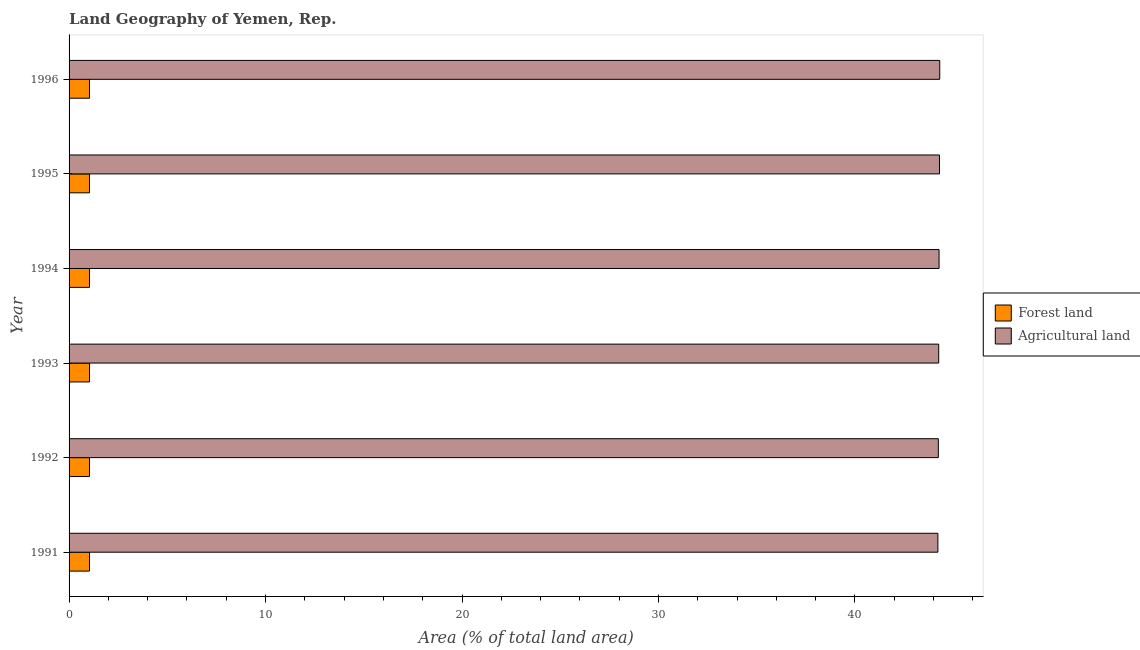How many different coloured bars are there?
Offer a very short reply. 2. How many groups of bars are there?
Ensure brevity in your answer.  6. Are the number of bars per tick equal to the number of legend labels?
Keep it short and to the point. Yes. How many bars are there on the 5th tick from the bottom?
Give a very brief answer. 2. What is the label of the 5th group of bars from the top?
Make the answer very short. 1992. In how many cases, is the number of bars for a given year not equal to the number of legend labels?
Give a very brief answer. 0. What is the percentage of land area under agriculture in 1994?
Your answer should be compact. 44.28. Across all years, what is the maximum percentage of land area under forests?
Provide a short and direct response. 1.04. Across all years, what is the minimum percentage of land area under agriculture?
Give a very brief answer. 44.22. What is the total percentage of land area under forests in the graph?
Provide a succinct answer. 6.24. What is the difference between the percentage of land area under forests in 1994 and the percentage of land area under agriculture in 1996?
Give a very brief answer. -43.28. What is the average percentage of land area under forests per year?
Provide a short and direct response. 1.04. In the year 1993, what is the difference between the percentage of land area under forests and percentage of land area under agriculture?
Make the answer very short. -43.22. In how many years, is the percentage of land area under agriculture greater than 36 %?
Your answer should be compact. 6. Is the percentage of land area under agriculture in 1994 less than that in 1996?
Your answer should be compact. Yes. Is the difference between the percentage of land area under agriculture in 1994 and 1995 greater than the difference between the percentage of land area under forests in 1994 and 1995?
Offer a very short reply. No. What is the difference between the highest and the second highest percentage of land area under forests?
Provide a succinct answer. 0. What is the difference between the highest and the lowest percentage of land area under agriculture?
Provide a short and direct response. 0.09. In how many years, is the percentage of land area under forests greater than the average percentage of land area under forests taken over all years?
Your answer should be very brief. 6. Is the sum of the percentage of land area under forests in 1993 and 1996 greater than the maximum percentage of land area under agriculture across all years?
Ensure brevity in your answer.  No. What does the 1st bar from the top in 1992 represents?
Your response must be concise. Agricultural land. What does the 2nd bar from the bottom in 1996 represents?
Your answer should be very brief. Agricultural land. Are the values on the major ticks of X-axis written in scientific E-notation?
Provide a short and direct response. No. Does the graph contain grids?
Ensure brevity in your answer.  No. What is the title of the graph?
Offer a very short reply. Land Geography of Yemen, Rep. Does "Pregnant women" appear as one of the legend labels in the graph?
Provide a short and direct response. No. What is the label or title of the X-axis?
Your answer should be very brief. Area (% of total land area). What is the Area (% of total land area) in Forest land in 1991?
Provide a succinct answer. 1.04. What is the Area (% of total land area) of Agricultural land in 1991?
Keep it short and to the point. 44.22. What is the Area (% of total land area) in Forest land in 1992?
Make the answer very short. 1.04. What is the Area (% of total land area) in Agricultural land in 1992?
Ensure brevity in your answer.  44.24. What is the Area (% of total land area) of Forest land in 1993?
Your answer should be compact. 1.04. What is the Area (% of total land area) of Agricultural land in 1993?
Keep it short and to the point. 44.26. What is the Area (% of total land area) of Forest land in 1994?
Keep it short and to the point. 1.04. What is the Area (% of total land area) in Agricultural land in 1994?
Offer a terse response. 44.28. What is the Area (% of total land area) of Forest land in 1995?
Ensure brevity in your answer.  1.04. What is the Area (% of total land area) in Agricultural land in 1995?
Your answer should be compact. 44.3. What is the Area (% of total land area) in Forest land in 1996?
Keep it short and to the point. 1.04. What is the Area (% of total land area) of Agricultural land in 1996?
Provide a short and direct response. 44.32. Across all years, what is the maximum Area (% of total land area) of Forest land?
Give a very brief answer. 1.04. Across all years, what is the maximum Area (% of total land area) of Agricultural land?
Your response must be concise. 44.32. Across all years, what is the minimum Area (% of total land area) in Forest land?
Offer a very short reply. 1.04. Across all years, what is the minimum Area (% of total land area) in Agricultural land?
Your answer should be very brief. 44.22. What is the total Area (% of total land area) in Forest land in the graph?
Offer a terse response. 6.24. What is the total Area (% of total land area) in Agricultural land in the graph?
Provide a short and direct response. 265.63. What is the difference between the Area (% of total land area) in Agricultural land in 1991 and that in 1992?
Offer a very short reply. -0.02. What is the difference between the Area (% of total land area) in Forest land in 1991 and that in 1993?
Offer a very short reply. 0. What is the difference between the Area (% of total land area) of Agricultural land in 1991 and that in 1993?
Your answer should be compact. -0.04. What is the difference between the Area (% of total land area) of Forest land in 1991 and that in 1994?
Your answer should be compact. 0. What is the difference between the Area (% of total land area) in Agricultural land in 1991 and that in 1994?
Your answer should be very brief. -0.06. What is the difference between the Area (% of total land area) of Agricultural land in 1991 and that in 1995?
Provide a short and direct response. -0.08. What is the difference between the Area (% of total land area) in Forest land in 1991 and that in 1996?
Provide a succinct answer. 0. What is the difference between the Area (% of total land area) in Agricultural land in 1991 and that in 1996?
Provide a succinct answer. -0.09. What is the difference between the Area (% of total land area) in Forest land in 1992 and that in 1993?
Your response must be concise. 0. What is the difference between the Area (% of total land area) of Agricultural land in 1992 and that in 1993?
Offer a terse response. -0.02. What is the difference between the Area (% of total land area) in Forest land in 1992 and that in 1994?
Offer a very short reply. 0. What is the difference between the Area (% of total land area) in Agricultural land in 1992 and that in 1994?
Your response must be concise. -0.04. What is the difference between the Area (% of total land area) in Forest land in 1992 and that in 1995?
Offer a terse response. 0. What is the difference between the Area (% of total land area) in Agricultural land in 1992 and that in 1995?
Keep it short and to the point. -0.06. What is the difference between the Area (% of total land area) of Agricultural land in 1992 and that in 1996?
Provide a succinct answer. -0.07. What is the difference between the Area (% of total land area) of Forest land in 1993 and that in 1994?
Provide a short and direct response. 0. What is the difference between the Area (% of total land area) in Agricultural land in 1993 and that in 1994?
Provide a short and direct response. -0.02. What is the difference between the Area (% of total land area) of Forest land in 1993 and that in 1995?
Your answer should be very brief. 0. What is the difference between the Area (% of total land area) of Agricultural land in 1993 and that in 1995?
Provide a short and direct response. -0.04. What is the difference between the Area (% of total land area) of Forest land in 1993 and that in 1996?
Your answer should be very brief. 0. What is the difference between the Area (% of total land area) of Agricultural land in 1993 and that in 1996?
Offer a terse response. -0.05. What is the difference between the Area (% of total land area) in Agricultural land in 1994 and that in 1995?
Offer a very short reply. -0.02. What is the difference between the Area (% of total land area) in Forest land in 1994 and that in 1996?
Give a very brief answer. 0. What is the difference between the Area (% of total land area) in Agricultural land in 1994 and that in 1996?
Keep it short and to the point. -0.03. What is the difference between the Area (% of total land area) of Forest land in 1995 and that in 1996?
Your answer should be compact. 0. What is the difference between the Area (% of total land area) of Agricultural land in 1995 and that in 1996?
Ensure brevity in your answer.  -0.01. What is the difference between the Area (% of total land area) in Forest land in 1991 and the Area (% of total land area) in Agricultural land in 1992?
Provide a short and direct response. -43.21. What is the difference between the Area (% of total land area) of Forest land in 1991 and the Area (% of total land area) of Agricultural land in 1993?
Make the answer very short. -43.22. What is the difference between the Area (% of total land area) of Forest land in 1991 and the Area (% of total land area) of Agricultural land in 1994?
Offer a terse response. -43.24. What is the difference between the Area (% of total land area) in Forest land in 1991 and the Area (% of total land area) in Agricultural land in 1995?
Keep it short and to the point. -43.26. What is the difference between the Area (% of total land area) of Forest land in 1991 and the Area (% of total land area) of Agricultural land in 1996?
Provide a succinct answer. -43.28. What is the difference between the Area (% of total land area) in Forest land in 1992 and the Area (% of total land area) in Agricultural land in 1993?
Your response must be concise. -43.22. What is the difference between the Area (% of total land area) of Forest land in 1992 and the Area (% of total land area) of Agricultural land in 1994?
Your answer should be compact. -43.24. What is the difference between the Area (% of total land area) of Forest land in 1992 and the Area (% of total land area) of Agricultural land in 1995?
Keep it short and to the point. -43.26. What is the difference between the Area (% of total land area) of Forest land in 1992 and the Area (% of total land area) of Agricultural land in 1996?
Ensure brevity in your answer.  -43.28. What is the difference between the Area (% of total land area) in Forest land in 1993 and the Area (% of total land area) in Agricultural land in 1994?
Provide a succinct answer. -43.24. What is the difference between the Area (% of total land area) in Forest land in 1993 and the Area (% of total land area) in Agricultural land in 1995?
Make the answer very short. -43.26. What is the difference between the Area (% of total land area) in Forest land in 1993 and the Area (% of total land area) in Agricultural land in 1996?
Ensure brevity in your answer.  -43.28. What is the difference between the Area (% of total land area) in Forest land in 1994 and the Area (% of total land area) in Agricultural land in 1995?
Offer a very short reply. -43.26. What is the difference between the Area (% of total land area) in Forest land in 1994 and the Area (% of total land area) in Agricultural land in 1996?
Your answer should be compact. -43.28. What is the difference between the Area (% of total land area) of Forest land in 1995 and the Area (% of total land area) of Agricultural land in 1996?
Your response must be concise. -43.28. What is the average Area (% of total land area) in Forest land per year?
Offer a terse response. 1.04. What is the average Area (% of total land area) of Agricultural land per year?
Your answer should be very brief. 44.27. In the year 1991, what is the difference between the Area (% of total land area) of Forest land and Area (% of total land area) of Agricultural land?
Ensure brevity in your answer.  -43.18. In the year 1992, what is the difference between the Area (% of total land area) in Forest land and Area (% of total land area) in Agricultural land?
Offer a very short reply. -43.21. In the year 1993, what is the difference between the Area (% of total land area) of Forest land and Area (% of total land area) of Agricultural land?
Provide a succinct answer. -43.22. In the year 1994, what is the difference between the Area (% of total land area) of Forest land and Area (% of total land area) of Agricultural land?
Give a very brief answer. -43.24. In the year 1995, what is the difference between the Area (% of total land area) in Forest land and Area (% of total land area) in Agricultural land?
Make the answer very short. -43.26. In the year 1996, what is the difference between the Area (% of total land area) in Forest land and Area (% of total land area) in Agricultural land?
Give a very brief answer. -43.28. What is the ratio of the Area (% of total land area) of Agricultural land in 1991 to that in 1992?
Offer a terse response. 1. What is the ratio of the Area (% of total land area) in Forest land in 1991 to that in 1995?
Your answer should be compact. 1. What is the ratio of the Area (% of total land area) of Agricultural land in 1991 to that in 1995?
Offer a very short reply. 1. What is the ratio of the Area (% of total land area) in Forest land in 1992 to that in 1993?
Offer a very short reply. 1. What is the ratio of the Area (% of total land area) in Forest land in 1992 to that in 1995?
Your answer should be compact. 1. What is the ratio of the Area (% of total land area) of Forest land in 1992 to that in 1996?
Make the answer very short. 1. What is the ratio of the Area (% of total land area) of Agricultural land in 1992 to that in 1996?
Your response must be concise. 1. What is the ratio of the Area (% of total land area) in Agricultural land in 1993 to that in 1994?
Provide a short and direct response. 1. What is the ratio of the Area (% of total land area) of Forest land in 1993 to that in 1995?
Provide a short and direct response. 1. What is the ratio of the Area (% of total land area) of Agricultural land in 1993 to that in 1995?
Provide a succinct answer. 1. What is the ratio of the Area (% of total land area) of Forest land in 1993 to that in 1996?
Your response must be concise. 1. What is the ratio of the Area (% of total land area) of Agricultural land in 1994 to that in 1995?
Offer a very short reply. 1. What is the ratio of the Area (% of total land area) of Forest land in 1994 to that in 1996?
Your answer should be compact. 1. What is the ratio of the Area (% of total land area) in Agricultural land in 1994 to that in 1996?
Your answer should be very brief. 1. What is the ratio of the Area (% of total land area) of Forest land in 1995 to that in 1996?
Provide a succinct answer. 1. What is the ratio of the Area (% of total land area) of Agricultural land in 1995 to that in 1996?
Give a very brief answer. 1. What is the difference between the highest and the second highest Area (% of total land area) in Agricultural land?
Offer a very short reply. 0.01. What is the difference between the highest and the lowest Area (% of total land area) in Agricultural land?
Ensure brevity in your answer.  0.09. 